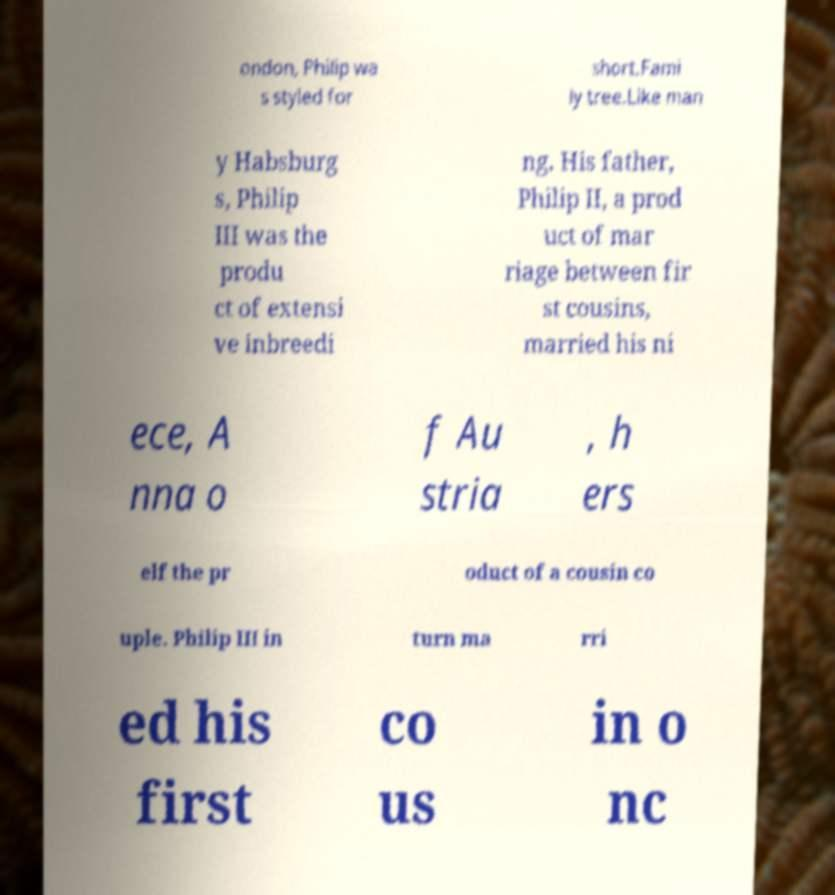For documentation purposes, I need the text within this image transcribed. Could you provide that? ondon, Philip wa s styled for short.Fami ly tree.Like man y Habsburg s, Philip III was the produ ct of extensi ve inbreedi ng. His father, Philip II, a prod uct of mar riage between fir st cousins, married his ni ece, A nna o f Au stria , h ers elf the pr oduct of a cousin co uple. Philip III in turn ma rri ed his first co us in o nc 